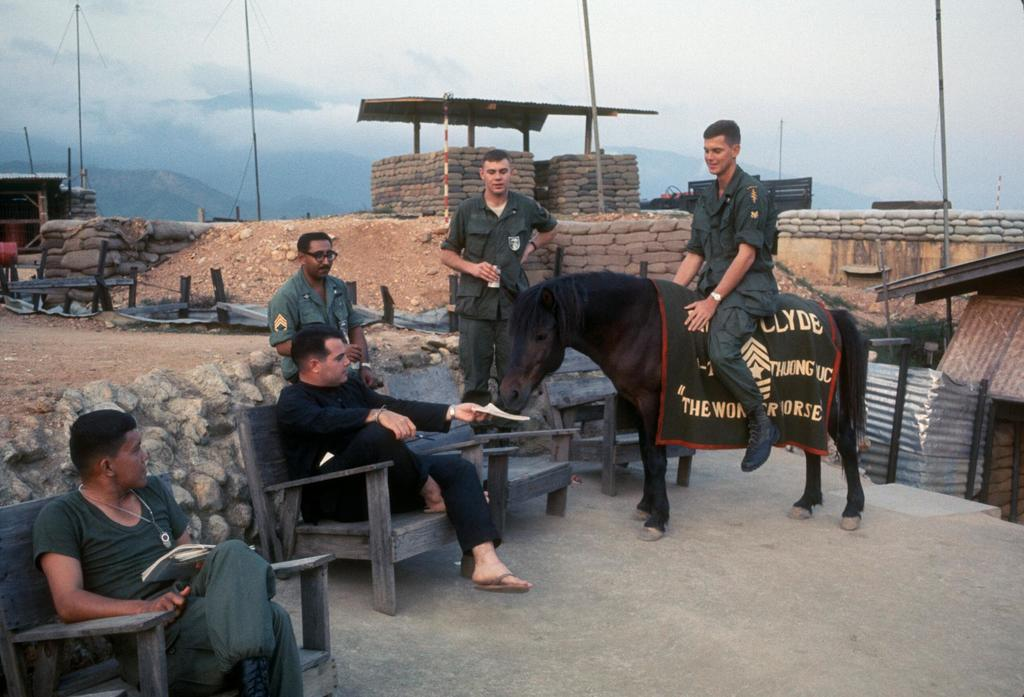How many people are in the image? There is a group of people in the image. What are the positions of the people in the image? Three people are seated, one person is standing, and one person is riding a horse. What is the condition of the sky in the image? The sky is blue and cloudy. What is the sister of the person riding the horse doing in the image? There is no mention of a sister in the image, so it cannot be determined what the sister might be doing. 